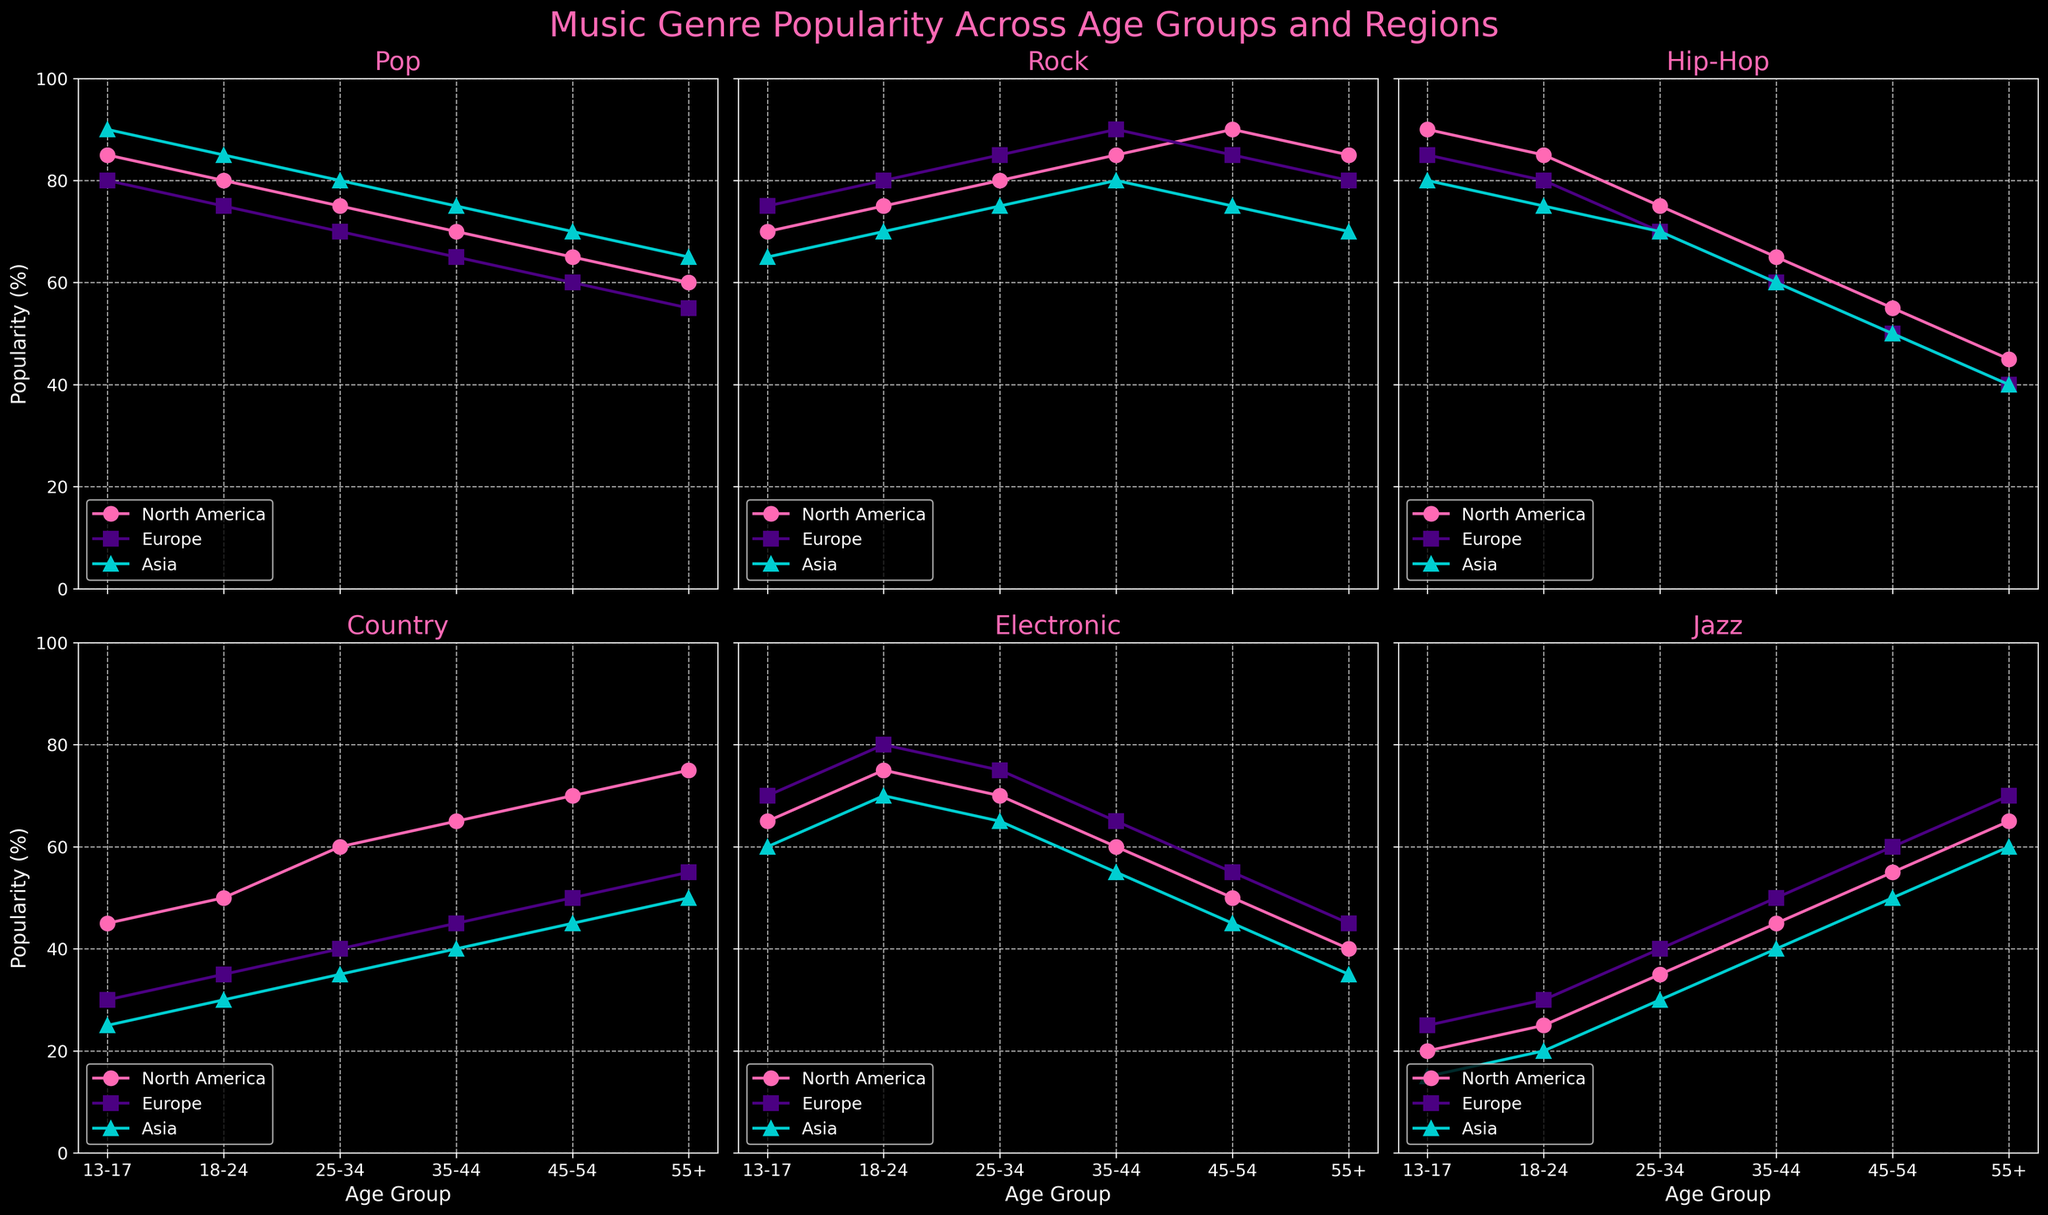What is the title of the figure? The title of a figure is usually written at the top in a larger and bolder font to give an overview of what the figure represents. In this case, it's placed above all the subplots.
Answer: Music Genre Popularity Across Age Groups and Regions How many genres of music are displayed in the figure? The different genres are used as titles for the subplots, so counting the unique titles will give the number of genres. In this figure, there are six different subplots, each representing a genre.
Answer: 6 Which music genre has the highest popularity among the 18-24 age group in North America? Look at the subplot for each genre and find the line representing North America (color and marker as per description) at the 18-24 age point, then compare the values. Hip-Hop shows the highest value for 18-24 in North America.
Answer: Hip-Hop What is the trend in popularity of Pop music with increasing age in Europe? In the subplot for Pop music, observe the line corresponding to Europe and see how its values change as we move from younger to older age groups. The trend shows a decreasing pattern.
Answer: Decreasing Which genre shows the least variation in popularity across age groups in Asia? Look at all lines in the subplots for Asia and see which one remains relatively consistent across all age groups. Country music shows the least variation.
Answer: Country In which region is Jazz music most popular for the 55+ age group? Look at the Jazz subplot, and identify the highest point at the 55+ age group among all regions represented by different lines. Europe shows the highest popularity for Jazz in the 55+ age group.
Answer: Europe Compare the popularity of Rock music between the 13-17 age group in North America and Europe. Which region shows higher popularity? Check the subplot for Rock music, compare the two points corresponding to the 13-17 age group for North America and Europe. North America shows a value of 70, whereas Europe shows 75.
Answer: Europe What is the average popularity of Pop music across all age groups in Asia? In the Pop subplot, observe the values corresponding to Asia for all age groups (90, 85, 80, 75, 70, 65), sum them, and divide by the number of age groups (6).
Answer: 77.5 How does the popularity of Electronic music in North America for the 35-44 age group compare to that in Europe for the same age group? Check the Electronic subplot, identify the specific points for North America and Europe at the 35-44 age group. North America has 60 and Europe has 65 for the 35-44 age group.
Answer: Europe is more popular Is there a clear preference for any specific music genre among the 25-34 age group in all regions? Look at each subplot and the 25-34 age group points for all regions, noting which, if any, has noticeably higher values. No single genre stands out universally for 25-34 across all regions.
Answer: No 